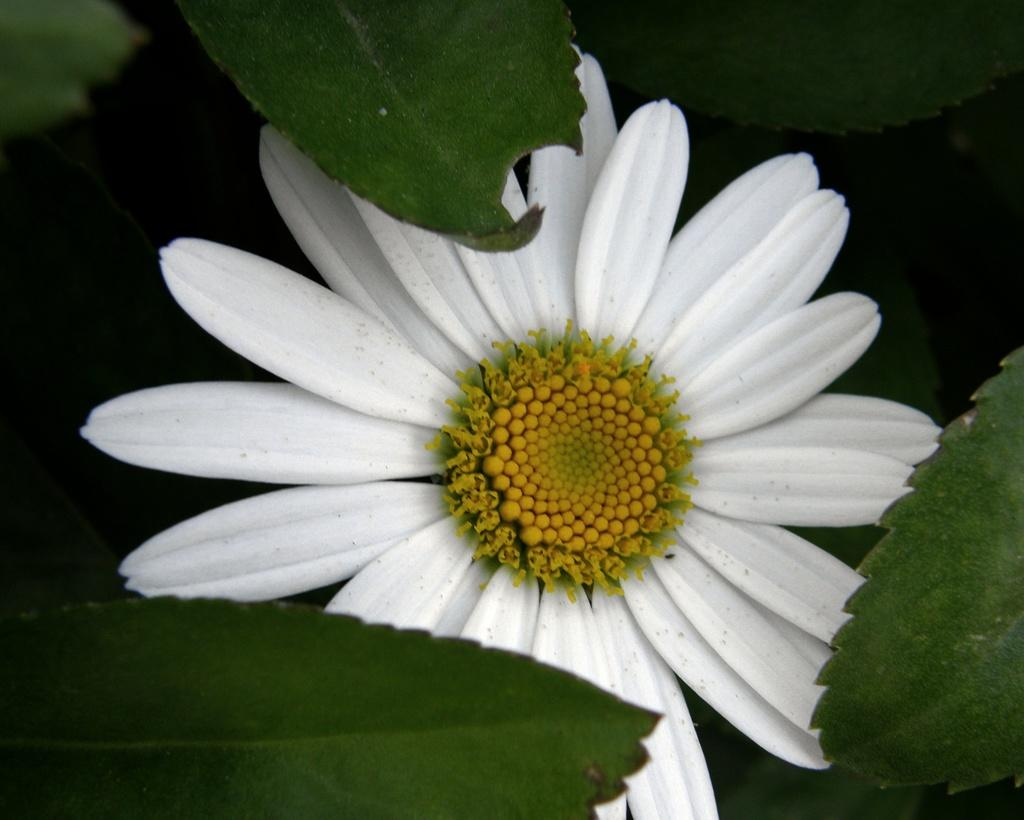What is present in the image? There is a plant in the image. Can you describe the plant's flower? The plant has a white flower. What type of underwear is hanging on the door in the image? There is no underwear or door present in the image; it only features a plant with a white flower. 